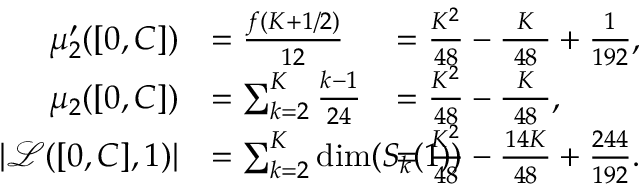Convert formula to latex. <formula><loc_0><loc_0><loc_500><loc_500>\begin{array} { r l r l } { \mu _ { 2 } ^ { \prime } ( [ 0 , C ] ) } & { = \frac { f ( K + 1 / 2 ) } { 1 2 } \, } & & { \, = \frac { K ^ { 2 } } { 4 8 } - \frac { K } { \, 4 8 \, } + \frac { 1 } { 1 9 2 } , } \\ { \mu _ { 2 } ( [ 0 , C ] ) } & { = \sum _ { k = 2 } ^ { K } \frac { k - 1 } { 2 4 } \, } & & { \, = \frac { K ^ { 2 } } { 4 8 } - \frac { K } { \, 4 8 \, } , } \\ { | { \mathcal { L } } ( [ 0 , C ] , 1 ) | } & { = \sum _ { k = 2 } ^ { K } \dim ( S _ { k } ( 1 ) ) \, } & & { \, = \frac { K ^ { 2 } } { 4 8 } - \frac { 1 4 K } { \, 4 8 \, } + \frac { 2 4 4 } { 1 9 2 } . } \end{array}</formula> 